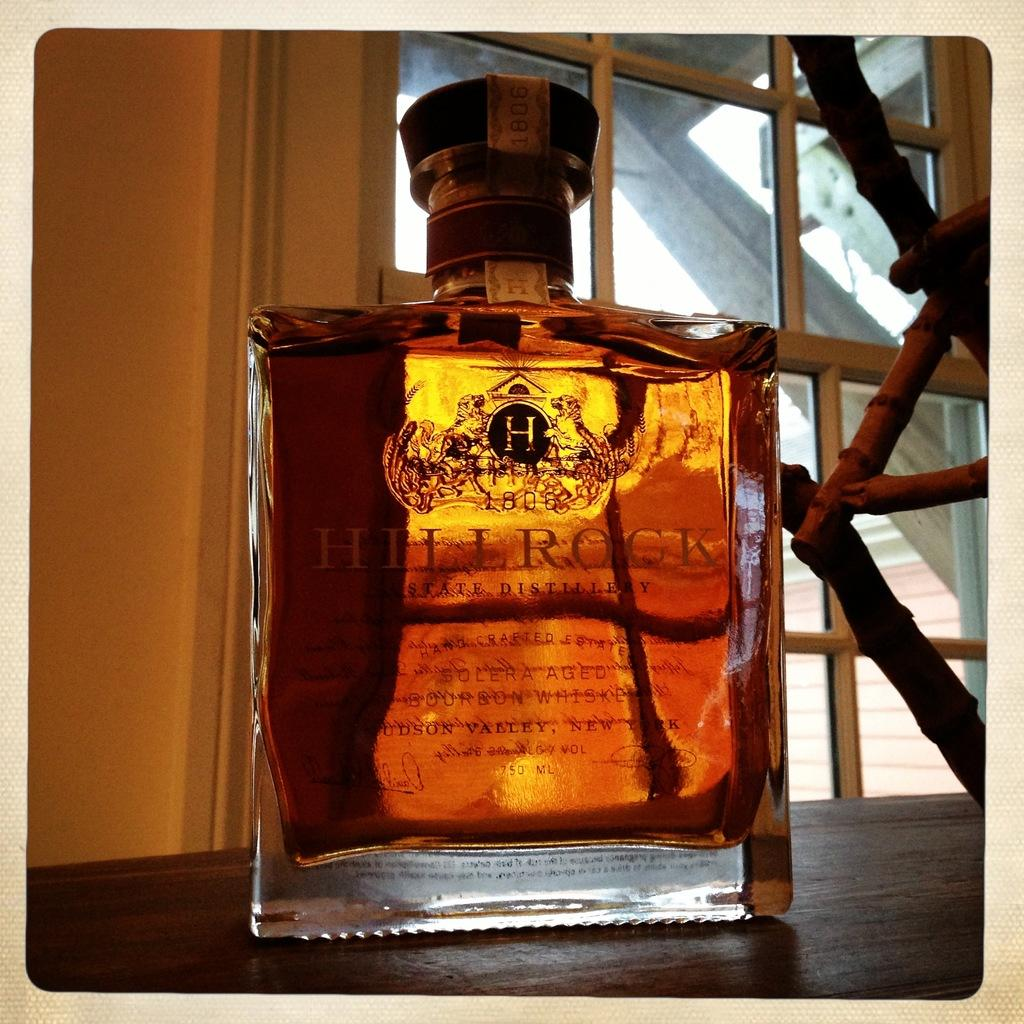<image>
Create a compact narrative representing the image presented. A light brown liquor with the name Hill Rock printed on it. 